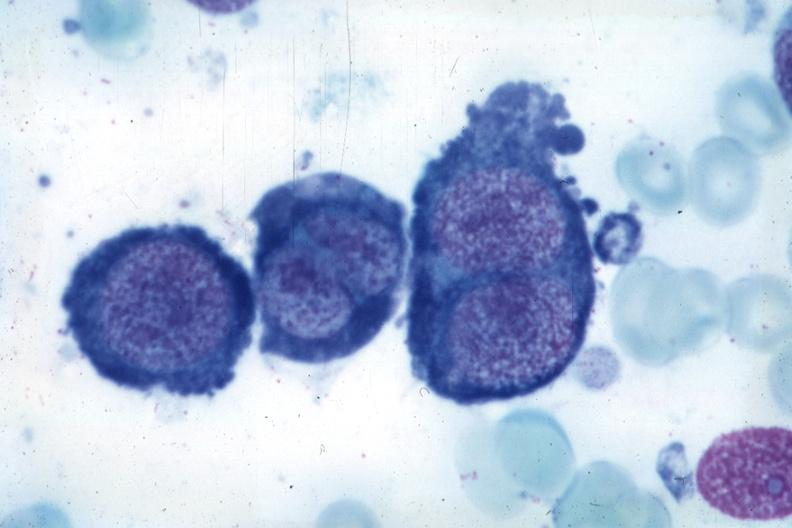s hematologic present?
Answer the question using a single word or phrase. Yes 